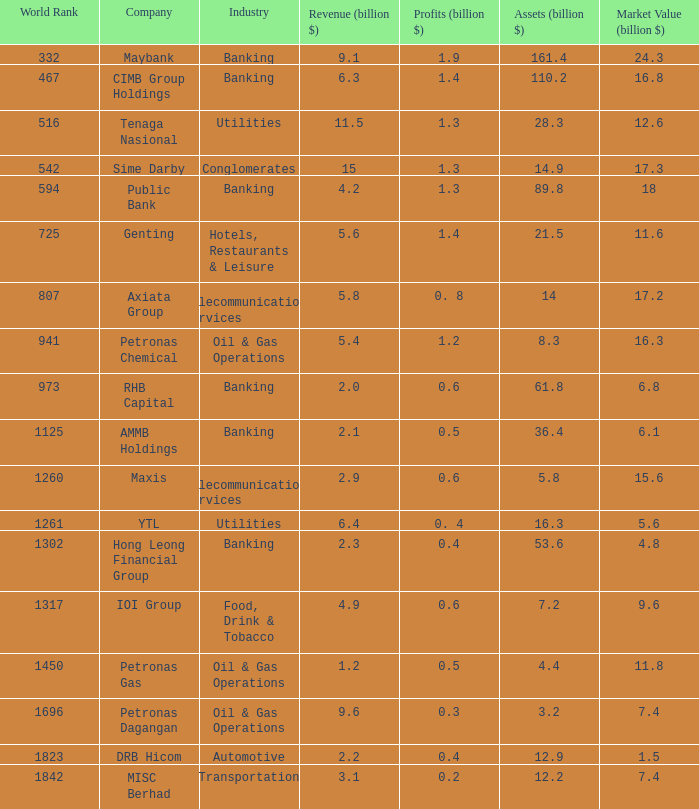Indicate the commercial area producing Banking. 